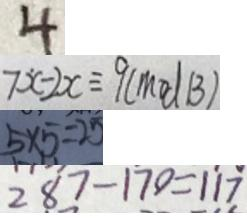<formula> <loc_0><loc_0><loc_500><loc_500>4 
 7 \dot { x } - 2 x \equiv 9 ( m o d B ) 
 5 \times 5 = 2 5 
 2 8 7 - 1 7 0 = 1 1 7</formula> 